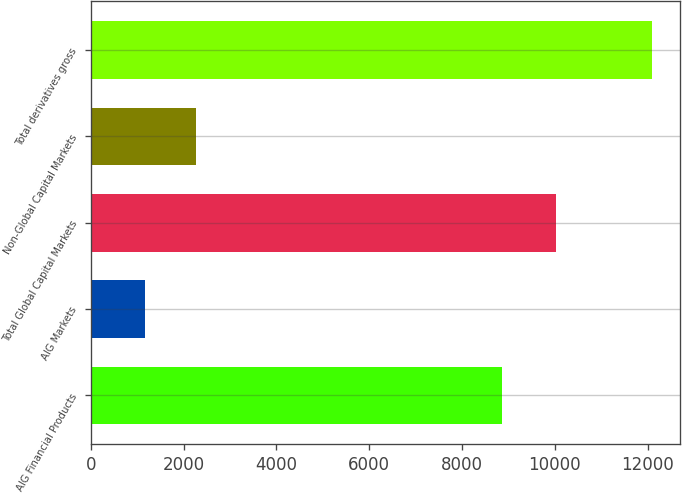Convert chart. <chart><loc_0><loc_0><loc_500><loc_500><bar_chart><fcel>AIG Financial Products<fcel>AIG Markets<fcel>Total Global Capital Markets<fcel>Non-Global Capital Markets<fcel>Total derivatives gross<nl><fcel>8853<fcel>1168<fcel>10021<fcel>2260.9<fcel>12097<nl></chart> 